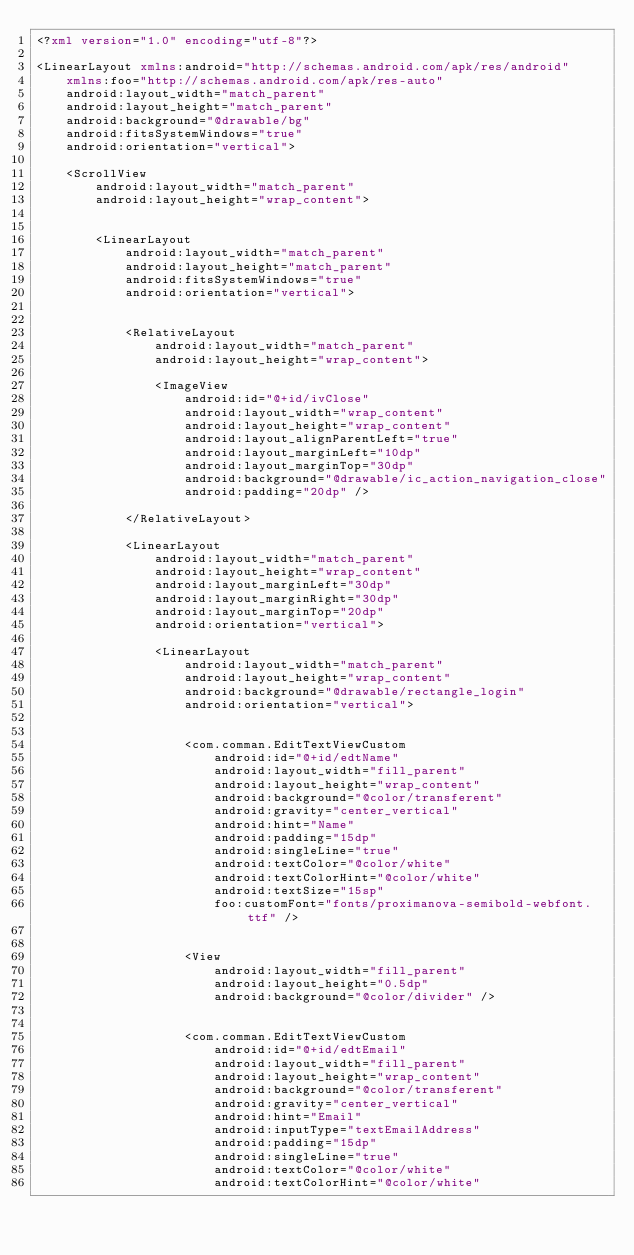<code> <loc_0><loc_0><loc_500><loc_500><_XML_><?xml version="1.0" encoding="utf-8"?>

<LinearLayout xmlns:android="http://schemas.android.com/apk/res/android"
    xmlns:foo="http://schemas.android.com/apk/res-auto"
    android:layout_width="match_parent"
    android:layout_height="match_parent"
    android:background="@drawable/bg"
    android:fitsSystemWindows="true"
    android:orientation="vertical">

    <ScrollView
        android:layout_width="match_parent"
        android:layout_height="wrap_content">


        <LinearLayout
            android:layout_width="match_parent"
            android:layout_height="match_parent"
            android:fitsSystemWindows="true"
            android:orientation="vertical">


            <RelativeLayout
                android:layout_width="match_parent"
                android:layout_height="wrap_content">

                <ImageView
                    android:id="@+id/ivClose"
                    android:layout_width="wrap_content"
                    android:layout_height="wrap_content"
                    android:layout_alignParentLeft="true"
                    android:layout_marginLeft="10dp"
                    android:layout_marginTop="30dp"
                    android:background="@drawable/ic_action_navigation_close"
                    android:padding="20dp" />

            </RelativeLayout>

            <LinearLayout
                android:layout_width="match_parent"
                android:layout_height="wrap_content"
                android:layout_marginLeft="30dp"
                android:layout_marginRight="30dp"
                android:layout_marginTop="20dp"
                android:orientation="vertical">

                <LinearLayout
                    android:layout_width="match_parent"
                    android:layout_height="wrap_content"
                    android:background="@drawable/rectangle_login"
                    android:orientation="vertical">


                    <com.comman.EditTextViewCustom
                        android:id="@+id/edtName"
                        android:layout_width="fill_parent"
                        android:layout_height="wrap_content"
                        android:background="@color/transferent"
                        android:gravity="center_vertical"
                        android:hint="Name"
                        android:padding="15dp"
                        android:singleLine="true"
                        android:textColor="@color/white"
                        android:textColorHint="@color/white"
                        android:textSize="15sp"
                        foo:customFont="fonts/proximanova-semibold-webfont.ttf" />


                    <View
                        android:layout_width="fill_parent"
                        android:layout_height="0.5dp"
                        android:background="@color/divider" />


                    <com.comman.EditTextViewCustom
                        android:id="@+id/edtEmail"
                        android:layout_width="fill_parent"
                        android:layout_height="wrap_content"
                        android:background="@color/transferent"
                        android:gravity="center_vertical"
                        android:hint="Email"
                        android:inputType="textEmailAddress"
                        android:padding="15dp"
                        android:singleLine="true"
                        android:textColor="@color/white"
                        android:textColorHint="@color/white"</code> 